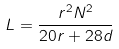<formula> <loc_0><loc_0><loc_500><loc_500>L = \frac { r ^ { 2 } N ^ { 2 } } { 2 0 r + 2 8 d }</formula> 